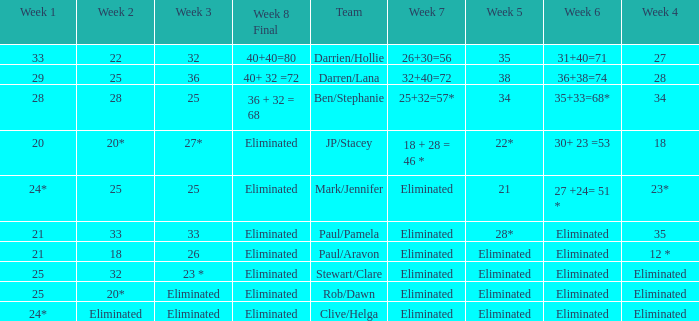Name the week 6 when week 3 is 25 and week 7 is eliminated 27 +24= 51 *. 